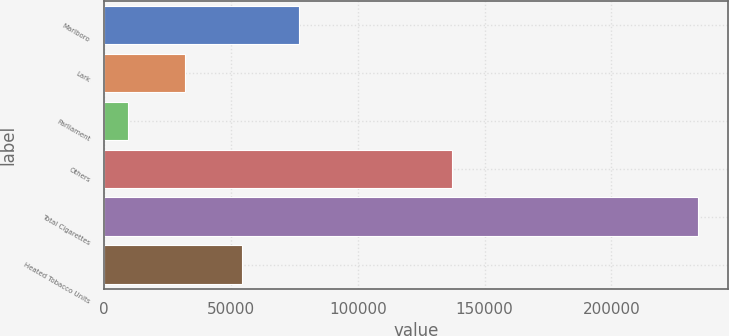<chart> <loc_0><loc_0><loc_500><loc_500><bar_chart><fcel>Marlboro<fcel>Lark<fcel>Parliament<fcel>Others<fcel>Total Cigarettes<fcel>Heated Tobacco Units<nl><fcel>76732.7<fcel>31726.9<fcel>9224<fcel>137109<fcel>234253<fcel>54229.8<nl></chart> 